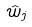<formula> <loc_0><loc_0><loc_500><loc_500>\hat { w } _ { j }</formula> 